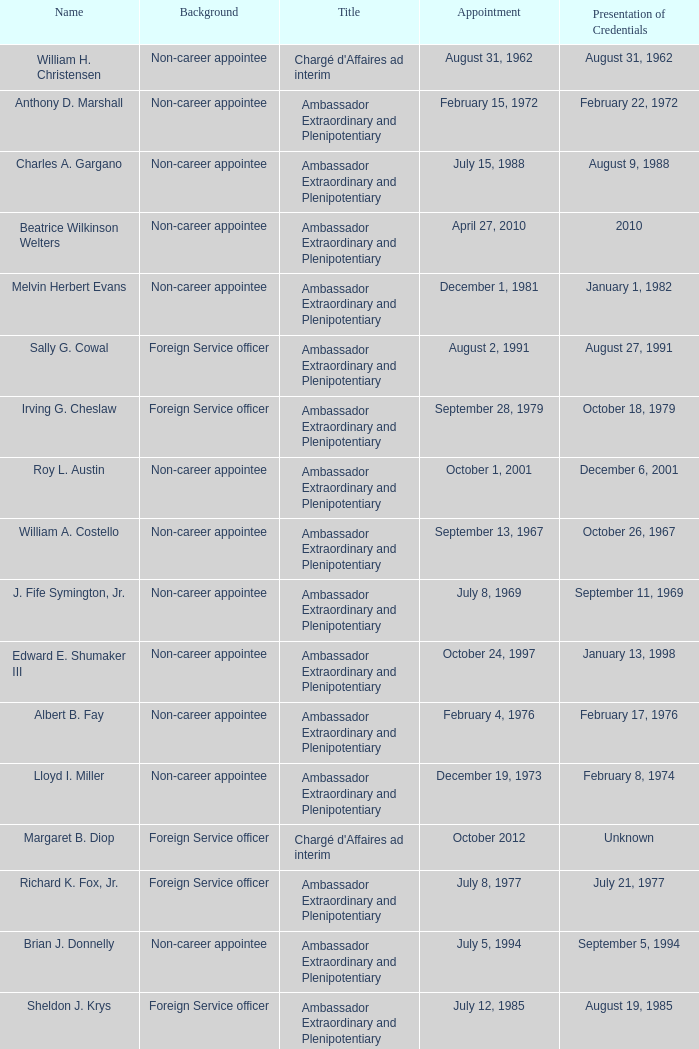When did robert g. miner display his certificates? December 1, 1962. 